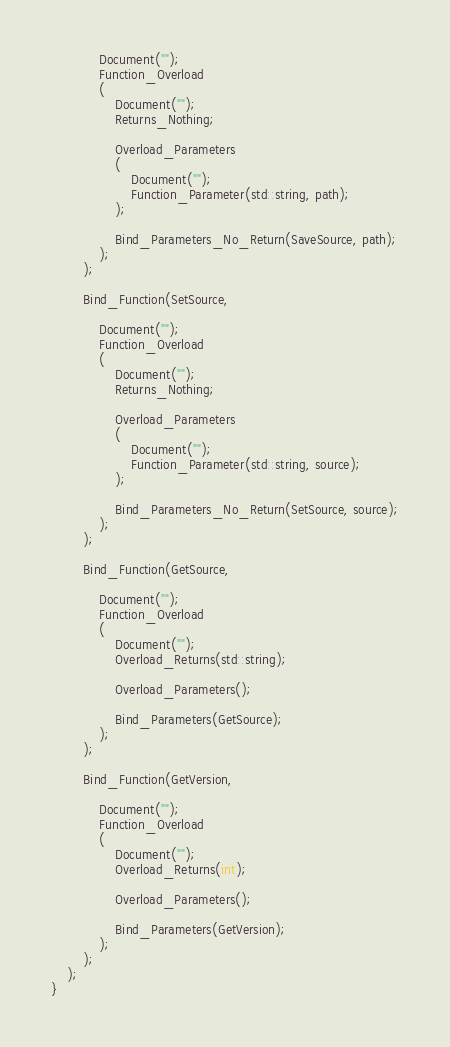<code> <loc_0><loc_0><loc_500><loc_500><_C++_>			Document("");
			Function_Overload
			(
				Document("");
				Returns_Nothing;

				Overload_Parameters
				(
					Document("");
					Function_Parameter(std::string, path);
				);

				Bind_Parameters_No_Return(SaveSource, path);
			);
		);
		
		Bind_Function(SetSource,

			Document("");
			Function_Overload
			(
				Document("");
				Returns_Nothing;

				Overload_Parameters
				(
					Document("");
					Function_Parameter(std::string, source);
				);

				Bind_Parameters_No_Return(SetSource, source);
			);
		);
		
		Bind_Function(GetSource,

			Document("");
			Function_Overload
			(
				Document("");
				Overload_Returns(std::string);

				Overload_Parameters();

				Bind_Parameters(GetSource);
			);
		);
		
		Bind_Function(GetVersion,

			Document("");
			Function_Overload
			(
				Document("");
				Overload_Returns(int);

				Overload_Parameters();

				Bind_Parameters(GetVersion);
			);
		);
	);
}
</code> 